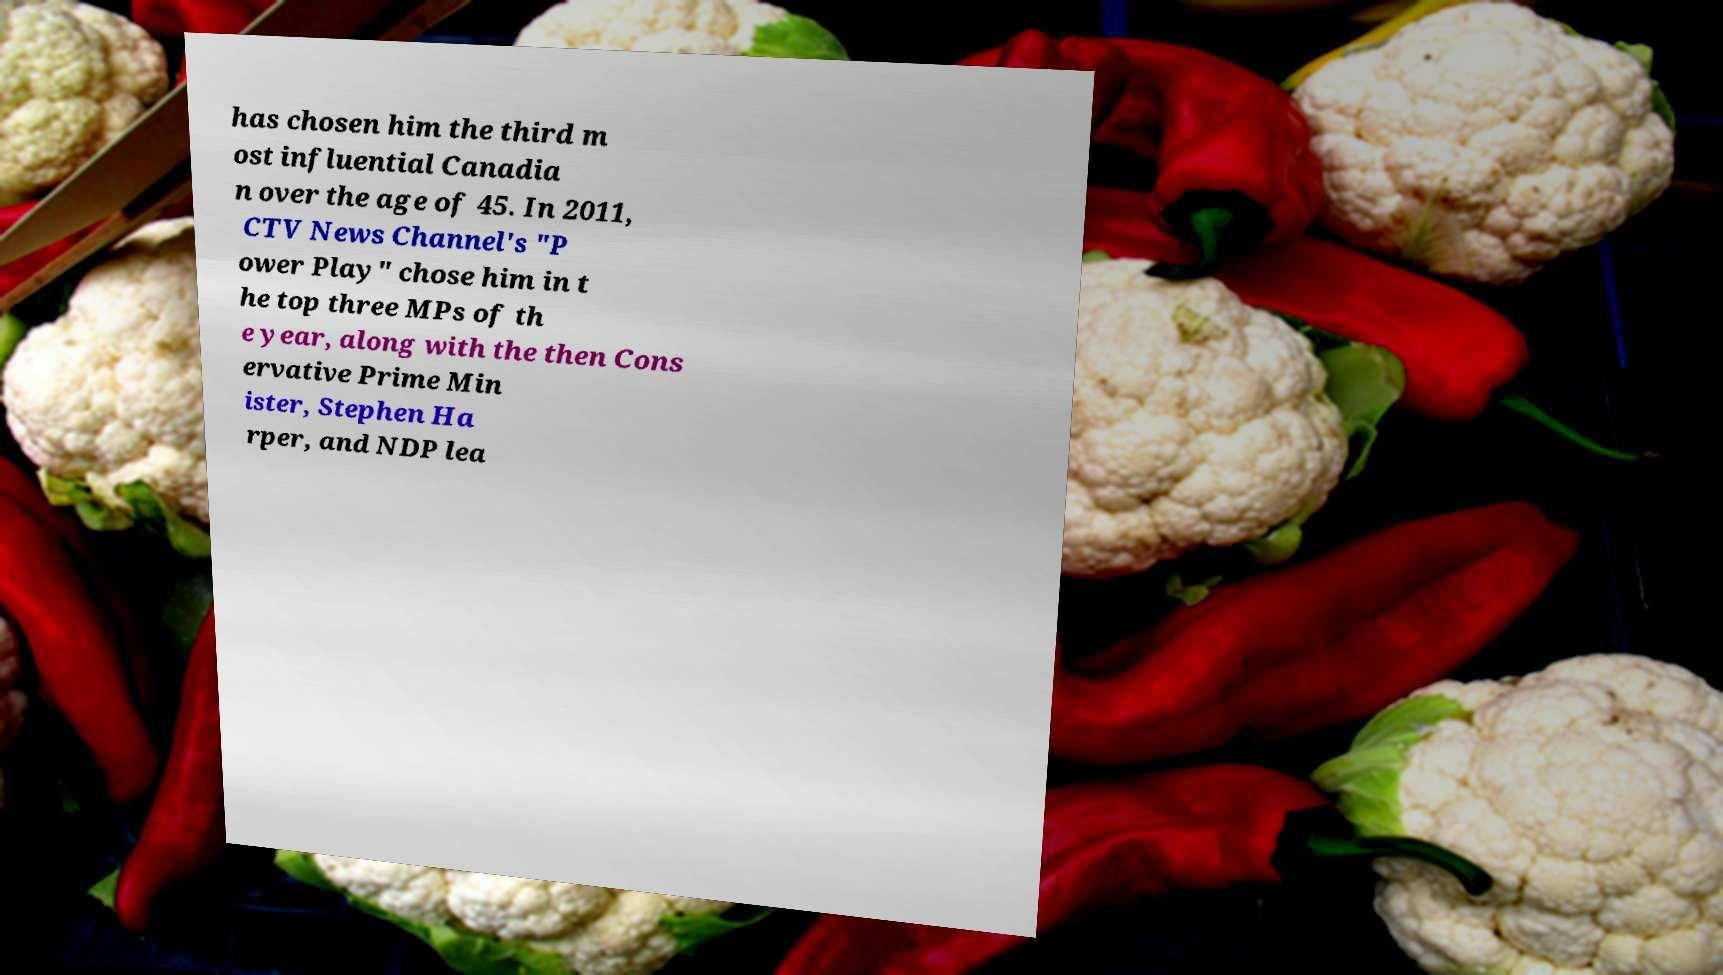Could you extract and type out the text from this image? has chosen him the third m ost influential Canadia n over the age of 45. In 2011, CTV News Channel's "P ower Play" chose him in t he top three MPs of th e year, along with the then Cons ervative Prime Min ister, Stephen Ha rper, and NDP lea 